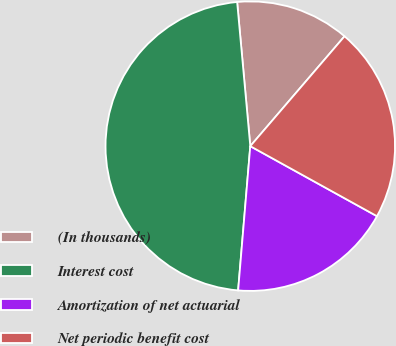Convert chart to OTSL. <chart><loc_0><loc_0><loc_500><loc_500><pie_chart><fcel>(In thousands)<fcel>Interest cost<fcel>Amortization of net actuarial<fcel>Net periodic benefit cost<nl><fcel>12.73%<fcel>47.21%<fcel>18.3%<fcel>21.75%<nl></chart> 